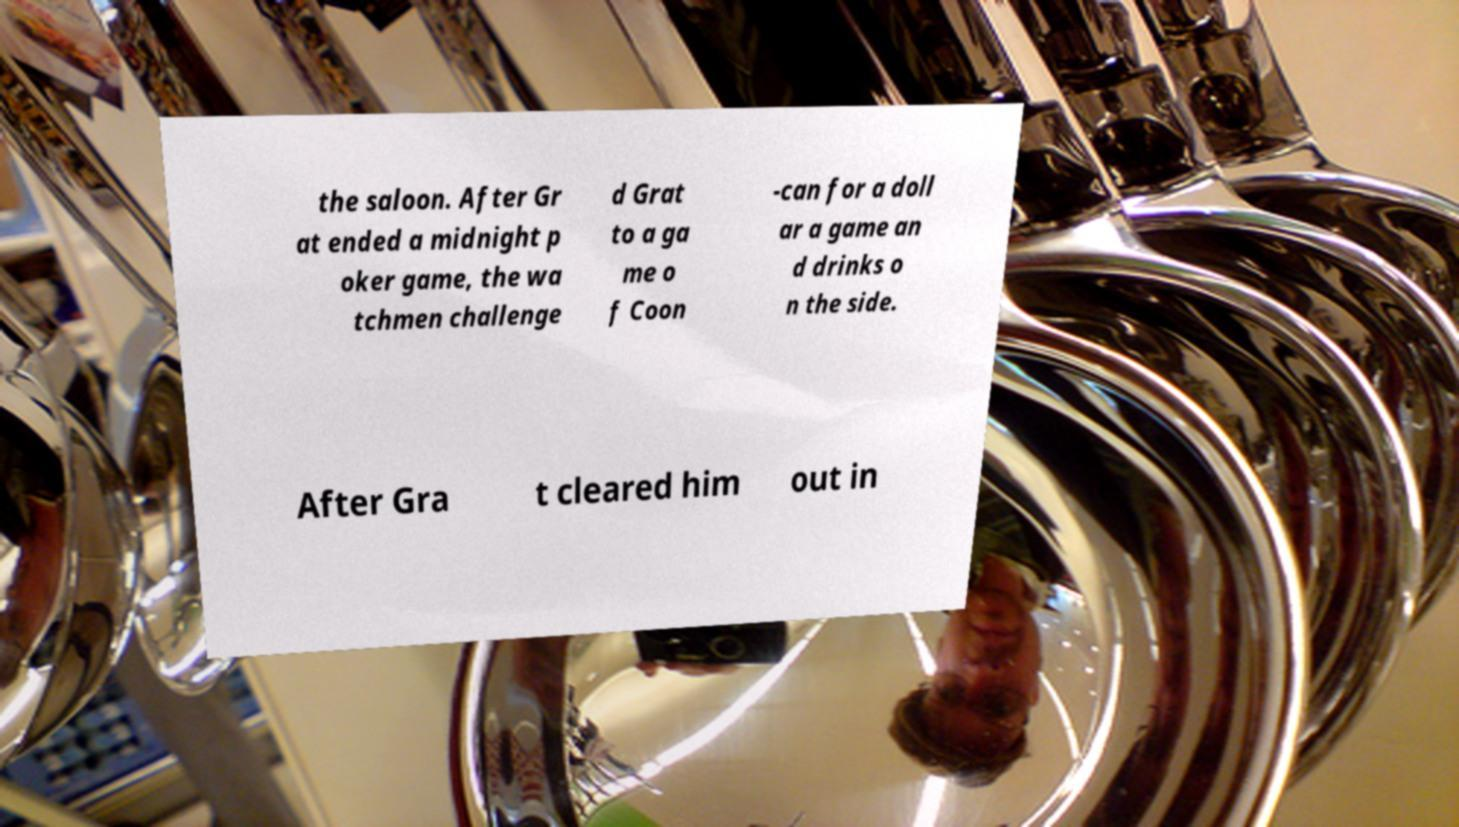Can you read and provide the text displayed in the image?This photo seems to have some interesting text. Can you extract and type it out for me? the saloon. After Gr at ended a midnight p oker game, the wa tchmen challenge d Grat to a ga me o f Coon -can for a doll ar a game an d drinks o n the side. After Gra t cleared him out in 